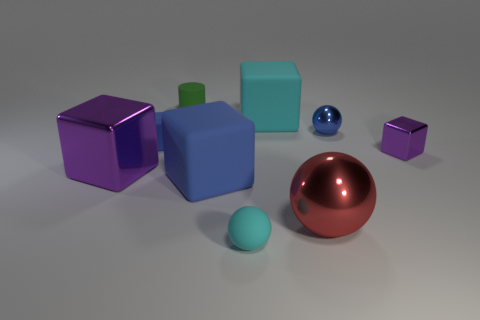Subtract all tiny rubber spheres. How many spheres are left? 2 Add 1 small blue balls. How many objects exist? 10 Subtract all cyan balls. How many balls are left? 2 Subtract 4 cubes. How many cubes are left? 1 Subtract all spheres. How many objects are left? 6 Add 1 big things. How many big things are left? 5 Add 6 big brown rubber spheres. How many big brown rubber spheres exist? 6 Subtract 0 gray cylinders. How many objects are left? 9 Subtract all cyan blocks. Subtract all purple cylinders. How many blocks are left? 4 Subtract all purple balls. How many purple blocks are left? 2 